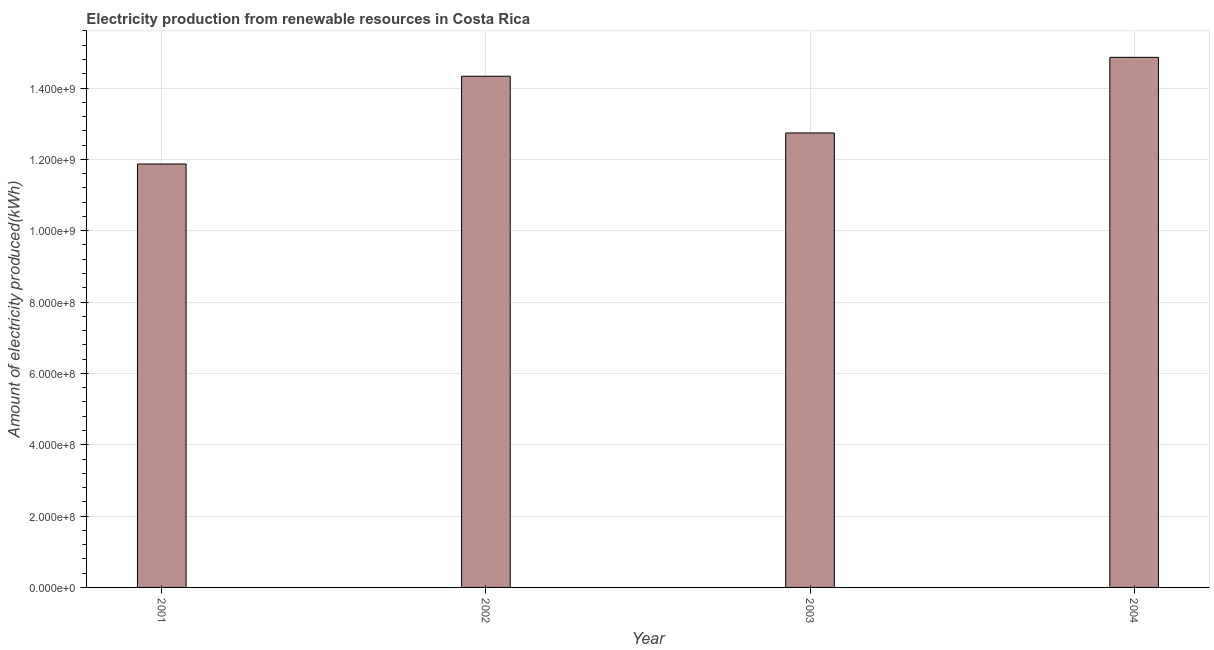Does the graph contain grids?
Provide a short and direct response. Yes. What is the title of the graph?
Provide a succinct answer. Electricity production from renewable resources in Costa Rica. What is the label or title of the Y-axis?
Give a very brief answer. Amount of electricity produced(kWh). What is the amount of electricity produced in 2003?
Give a very brief answer. 1.27e+09. Across all years, what is the maximum amount of electricity produced?
Your answer should be very brief. 1.49e+09. Across all years, what is the minimum amount of electricity produced?
Provide a short and direct response. 1.19e+09. What is the sum of the amount of electricity produced?
Provide a succinct answer. 5.38e+09. What is the difference between the amount of electricity produced in 2003 and 2004?
Your answer should be compact. -2.12e+08. What is the average amount of electricity produced per year?
Provide a short and direct response. 1.34e+09. What is the median amount of electricity produced?
Provide a succinct answer. 1.35e+09. What is the ratio of the amount of electricity produced in 2003 to that in 2004?
Provide a short and direct response. 0.86. What is the difference between the highest and the second highest amount of electricity produced?
Provide a short and direct response. 5.30e+07. Is the sum of the amount of electricity produced in 2001 and 2004 greater than the maximum amount of electricity produced across all years?
Provide a short and direct response. Yes. What is the difference between the highest and the lowest amount of electricity produced?
Your response must be concise. 2.99e+08. In how many years, is the amount of electricity produced greater than the average amount of electricity produced taken over all years?
Your response must be concise. 2. Are all the bars in the graph horizontal?
Provide a succinct answer. No. What is the Amount of electricity produced(kWh) in 2001?
Make the answer very short. 1.19e+09. What is the Amount of electricity produced(kWh) in 2002?
Your response must be concise. 1.43e+09. What is the Amount of electricity produced(kWh) of 2003?
Provide a short and direct response. 1.27e+09. What is the Amount of electricity produced(kWh) of 2004?
Make the answer very short. 1.49e+09. What is the difference between the Amount of electricity produced(kWh) in 2001 and 2002?
Ensure brevity in your answer.  -2.46e+08. What is the difference between the Amount of electricity produced(kWh) in 2001 and 2003?
Your answer should be very brief. -8.70e+07. What is the difference between the Amount of electricity produced(kWh) in 2001 and 2004?
Your answer should be very brief. -2.99e+08. What is the difference between the Amount of electricity produced(kWh) in 2002 and 2003?
Offer a very short reply. 1.59e+08. What is the difference between the Amount of electricity produced(kWh) in 2002 and 2004?
Make the answer very short. -5.30e+07. What is the difference between the Amount of electricity produced(kWh) in 2003 and 2004?
Your response must be concise. -2.12e+08. What is the ratio of the Amount of electricity produced(kWh) in 2001 to that in 2002?
Keep it short and to the point. 0.83. What is the ratio of the Amount of electricity produced(kWh) in 2001 to that in 2003?
Your answer should be very brief. 0.93. What is the ratio of the Amount of electricity produced(kWh) in 2001 to that in 2004?
Make the answer very short. 0.8. What is the ratio of the Amount of electricity produced(kWh) in 2003 to that in 2004?
Make the answer very short. 0.86. 